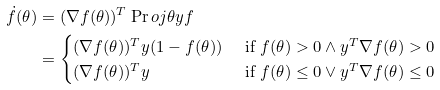<formula> <loc_0><loc_0><loc_500><loc_500>\dot { f } ( \theta ) & = ( \nabla f ( \theta ) ) ^ { T } \Pr o j { \theta } { y } { f } \\ & = \begin{cases} ( \nabla f ( \theta ) ) ^ { T } y ( 1 - f ( \theta ) ) & \text { if } f ( \theta ) > 0 \wedge y ^ { T } \nabla f ( \theta ) > 0 \\ ( \nabla f ( \theta ) ) ^ { T } y & \text { if } f ( \theta ) \leq 0 \vee y ^ { T } \nabla f ( \theta ) \leq 0 \end{cases}</formula> 